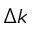Convert formula to latex. <formula><loc_0><loc_0><loc_500><loc_500>\Delta k</formula> 